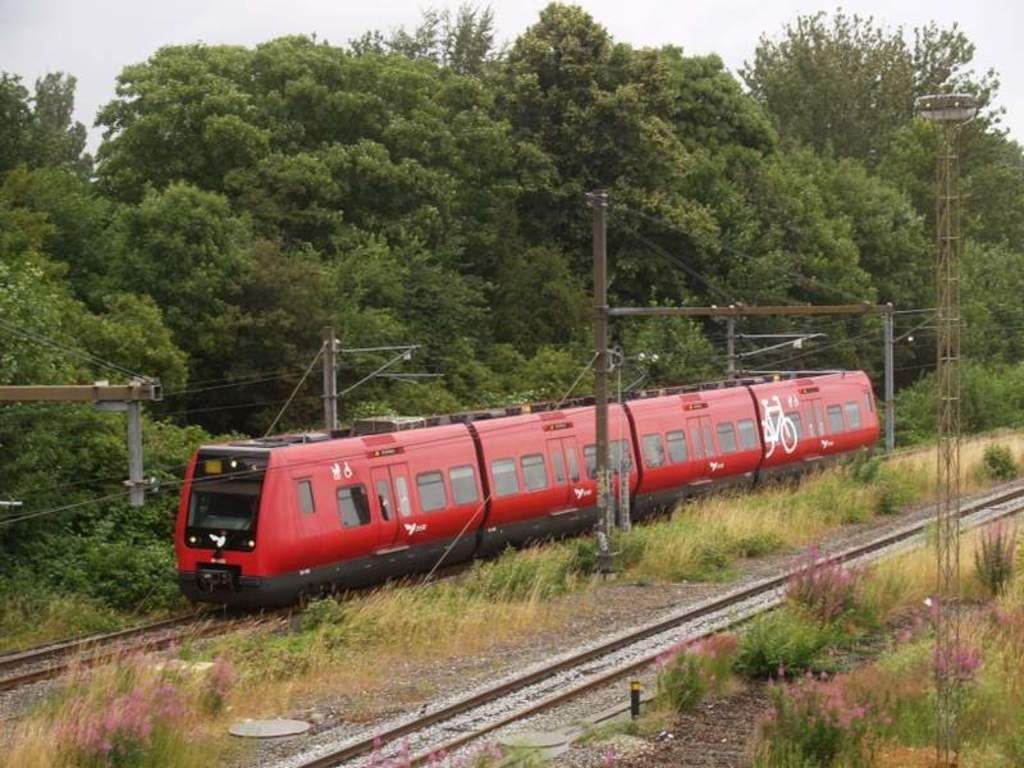What is located on the track in the image? There is a train on the track in the image. What type of vegetation can be seen in the image? There is grass visible in the image, and there are also trees. What structures are present in the image? There are poles in the image. Can you see an uncle holding a mitten in the image? There is no uncle or mitten present in the image. What type of feather can be seen on the train in the image? There are no feathers visible on the train or anywhere else in the image. 